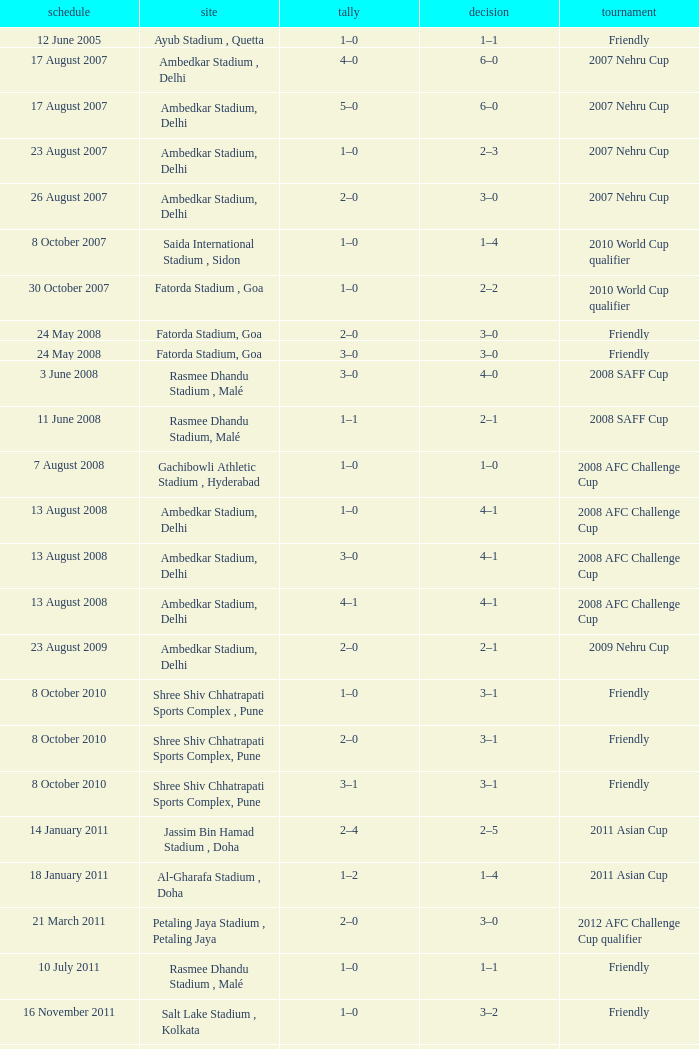Tell me the score on 22 august 2012 1–0. 